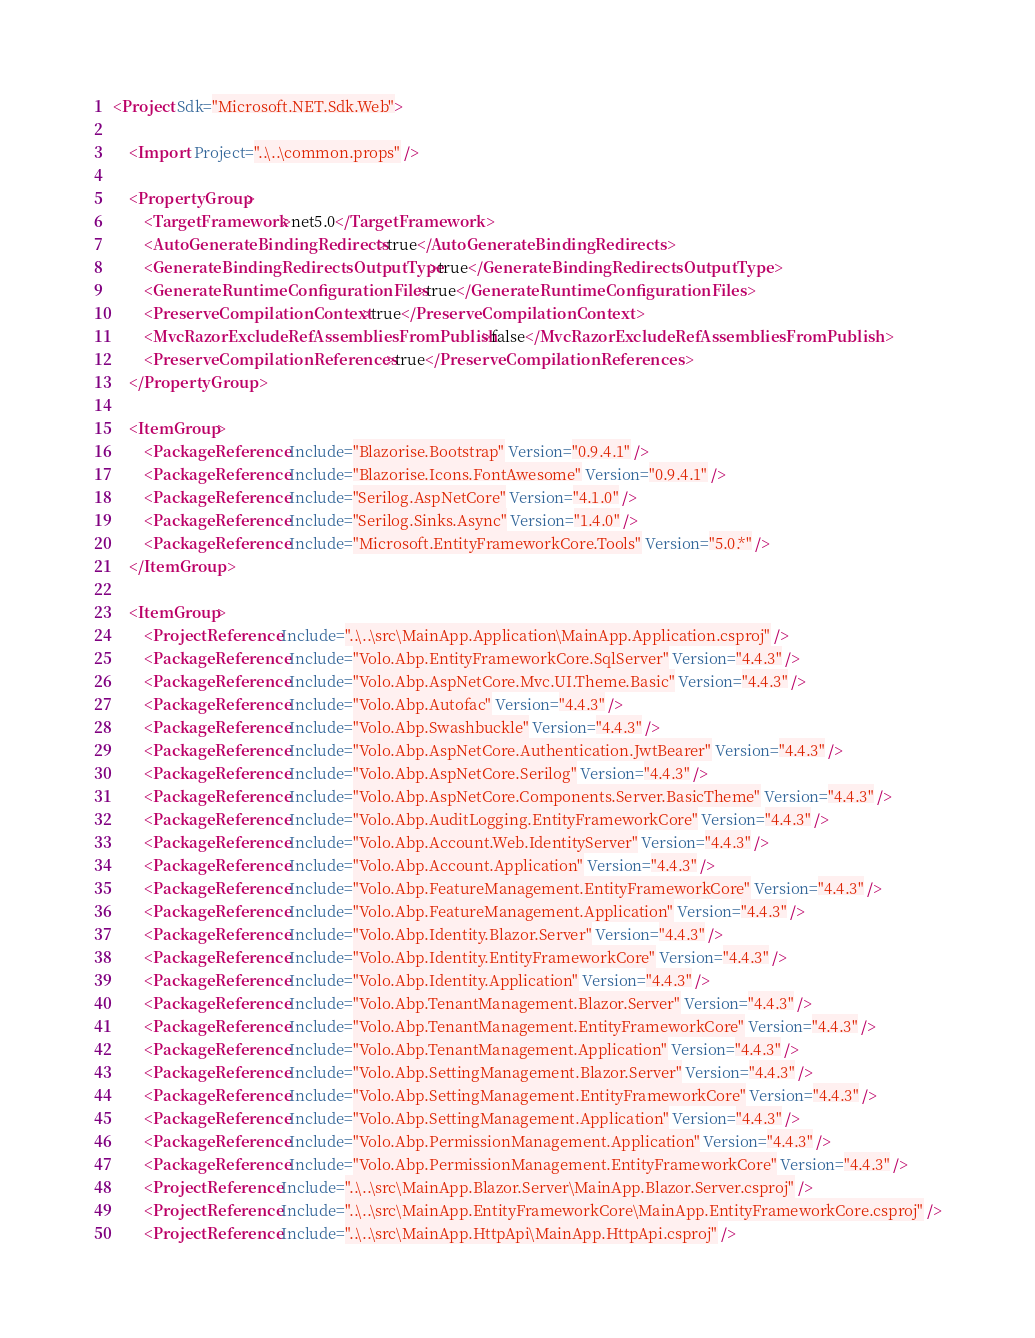<code> <loc_0><loc_0><loc_500><loc_500><_XML_><Project Sdk="Microsoft.NET.Sdk.Web">

    <Import Project="..\..\common.props" />

    <PropertyGroup>
        <TargetFramework>net5.0</TargetFramework>
        <AutoGenerateBindingRedirects>true</AutoGenerateBindingRedirects>
        <GenerateBindingRedirectsOutputType>true</GenerateBindingRedirectsOutputType>
        <GenerateRuntimeConfigurationFiles>true</GenerateRuntimeConfigurationFiles>
        <PreserveCompilationContext>true</PreserveCompilationContext>
        <MvcRazorExcludeRefAssembliesFromPublish>false</MvcRazorExcludeRefAssembliesFromPublish>
        <PreserveCompilationReferences>true</PreserveCompilationReferences>
    </PropertyGroup>

    <ItemGroup>
        <PackageReference Include="Blazorise.Bootstrap" Version="0.9.4.1" />
        <PackageReference Include="Blazorise.Icons.FontAwesome" Version="0.9.4.1" />
        <PackageReference Include="Serilog.AspNetCore" Version="4.1.0" />
        <PackageReference Include="Serilog.Sinks.Async" Version="1.4.0" />
        <PackageReference Include="Microsoft.EntityFrameworkCore.Tools" Version="5.0.*" />
    </ItemGroup>

    <ItemGroup>
        <ProjectReference Include="..\..\src\MainApp.Application\MainApp.Application.csproj" />
        <PackageReference Include="Volo.Abp.EntityFrameworkCore.SqlServer" Version="4.4.3" />
        <PackageReference Include="Volo.Abp.AspNetCore.Mvc.UI.Theme.Basic" Version="4.4.3" />
        <PackageReference Include="Volo.Abp.Autofac" Version="4.4.3" />
        <PackageReference Include="Volo.Abp.Swashbuckle" Version="4.4.3" />
        <PackageReference Include="Volo.Abp.AspNetCore.Authentication.JwtBearer" Version="4.4.3" />
        <PackageReference Include="Volo.Abp.AspNetCore.Serilog" Version="4.4.3" />
        <PackageReference Include="Volo.Abp.AspNetCore.Components.Server.BasicTheme" Version="4.4.3" />
        <PackageReference Include="Volo.Abp.AuditLogging.EntityFrameworkCore" Version="4.4.3" />
        <PackageReference Include="Volo.Abp.Account.Web.IdentityServer" Version="4.4.3" />
        <PackageReference Include="Volo.Abp.Account.Application" Version="4.4.3" />
        <PackageReference Include="Volo.Abp.FeatureManagement.EntityFrameworkCore" Version="4.4.3" />
        <PackageReference Include="Volo.Abp.FeatureManagement.Application" Version="4.4.3" />
        <PackageReference Include="Volo.Abp.Identity.Blazor.Server" Version="4.4.3" />
        <PackageReference Include="Volo.Abp.Identity.EntityFrameworkCore" Version="4.4.3" />
        <PackageReference Include="Volo.Abp.Identity.Application" Version="4.4.3" />
        <PackageReference Include="Volo.Abp.TenantManagement.Blazor.Server" Version="4.4.3" />
        <PackageReference Include="Volo.Abp.TenantManagement.EntityFrameworkCore" Version="4.4.3" />
        <PackageReference Include="Volo.Abp.TenantManagement.Application" Version="4.4.3" />
        <PackageReference Include="Volo.Abp.SettingManagement.Blazor.Server" Version="4.4.3" />
        <PackageReference Include="Volo.Abp.SettingManagement.EntityFrameworkCore" Version="4.4.3" />
        <PackageReference Include="Volo.Abp.SettingManagement.Application" Version="4.4.3" />
        <PackageReference Include="Volo.Abp.PermissionManagement.Application" Version="4.4.3" />
        <PackageReference Include="Volo.Abp.PermissionManagement.EntityFrameworkCore" Version="4.4.3" />
        <ProjectReference Include="..\..\src\MainApp.Blazor.Server\MainApp.Blazor.Server.csproj" />
        <ProjectReference Include="..\..\src\MainApp.EntityFrameworkCore\MainApp.EntityFrameworkCore.csproj" />
        <ProjectReference Include="..\..\src\MainApp.HttpApi\MainApp.HttpApi.csproj" /></code> 